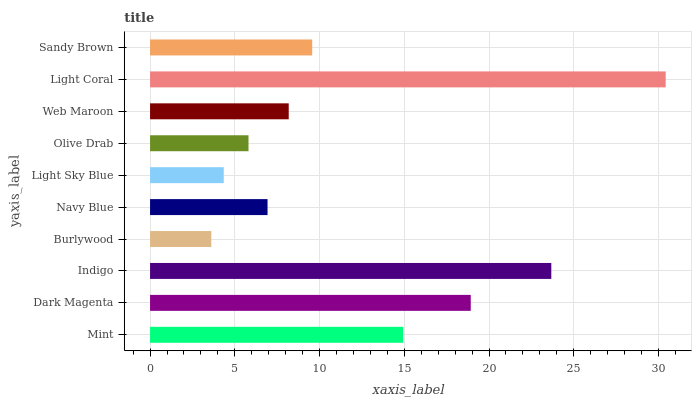Is Burlywood the minimum?
Answer yes or no. Yes. Is Light Coral the maximum?
Answer yes or no. Yes. Is Dark Magenta the minimum?
Answer yes or no. No. Is Dark Magenta the maximum?
Answer yes or no. No. Is Dark Magenta greater than Mint?
Answer yes or no. Yes. Is Mint less than Dark Magenta?
Answer yes or no. Yes. Is Mint greater than Dark Magenta?
Answer yes or no. No. Is Dark Magenta less than Mint?
Answer yes or no. No. Is Sandy Brown the high median?
Answer yes or no. Yes. Is Web Maroon the low median?
Answer yes or no. Yes. Is Olive Drab the high median?
Answer yes or no. No. Is Burlywood the low median?
Answer yes or no. No. 